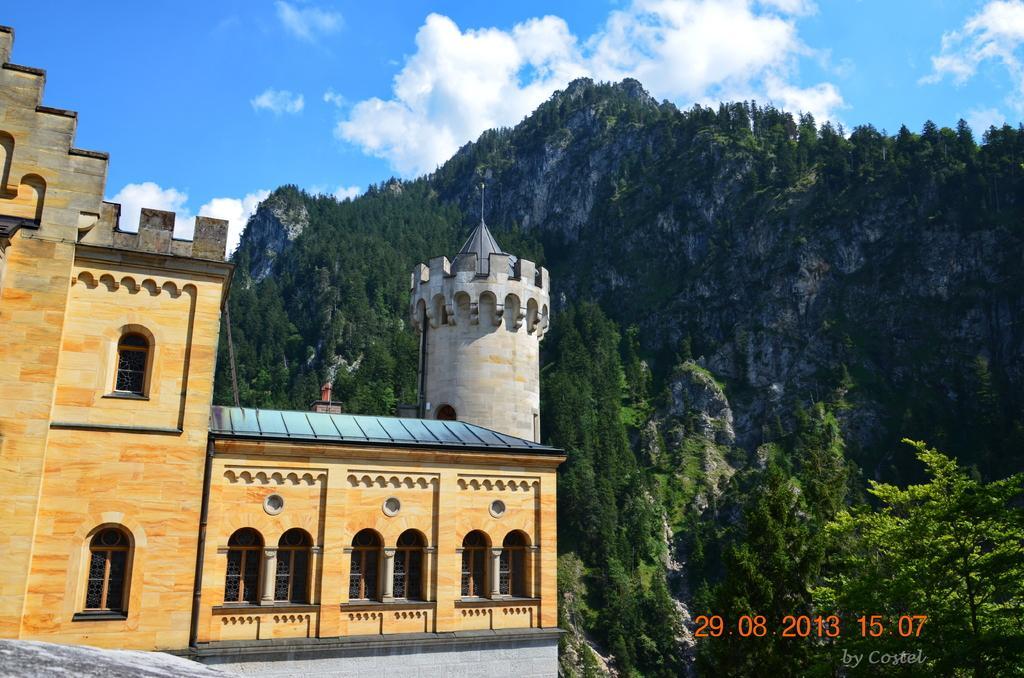How would you summarize this image in a sentence or two? In this image I can see a building in the front and I can also see number of trees on the right and behind the building. In the background I can see clouds, the sky and on the bottom right side of this image I can see a watermark. 